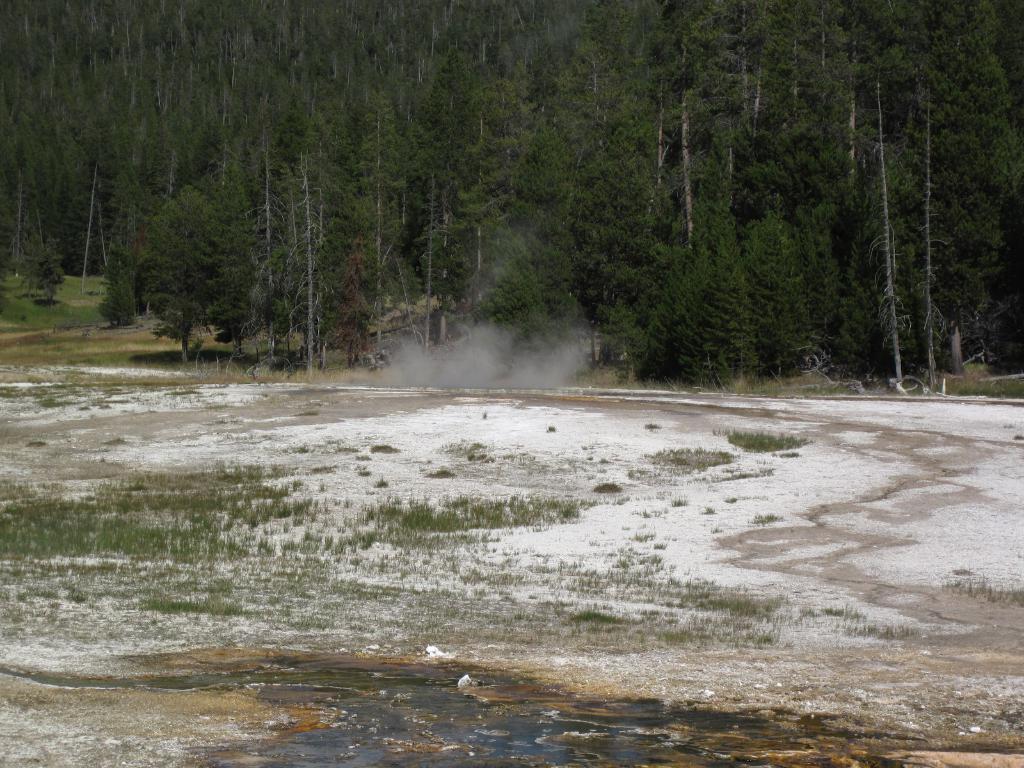Could you give a brief overview of what you see in this image? In the foreground of the picture there are grass, soil and smoke. In the background there are trees, plants and grass. It is sunny. 